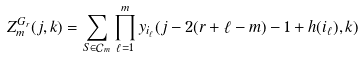Convert formula to latex. <formula><loc_0><loc_0><loc_500><loc_500>Z _ { m } ^ { G _ { r } } ( j , k ) = \sum _ { S \in \mathcal { C } _ { m } } \prod _ { \ell = 1 } ^ { m } y _ { i _ { \ell } } ( j - 2 ( r + \ell - m ) - 1 + h ( i _ { \ell } ) , k )</formula> 